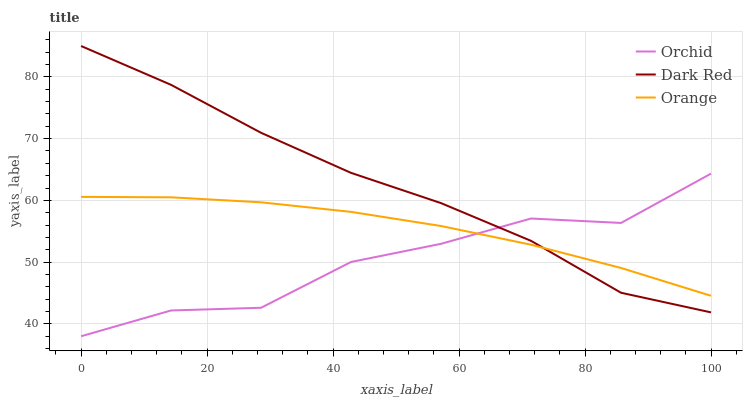Does Orchid have the minimum area under the curve?
Answer yes or no. Yes. Does Dark Red have the maximum area under the curve?
Answer yes or no. Yes. Does Dark Red have the minimum area under the curve?
Answer yes or no. No. Does Orchid have the maximum area under the curve?
Answer yes or no. No. Is Orange the smoothest?
Answer yes or no. Yes. Is Orchid the roughest?
Answer yes or no. Yes. Is Dark Red the smoothest?
Answer yes or no. No. Is Dark Red the roughest?
Answer yes or no. No. Does Dark Red have the lowest value?
Answer yes or no. No. Does Dark Red have the highest value?
Answer yes or no. Yes. Does Orchid have the highest value?
Answer yes or no. No. 